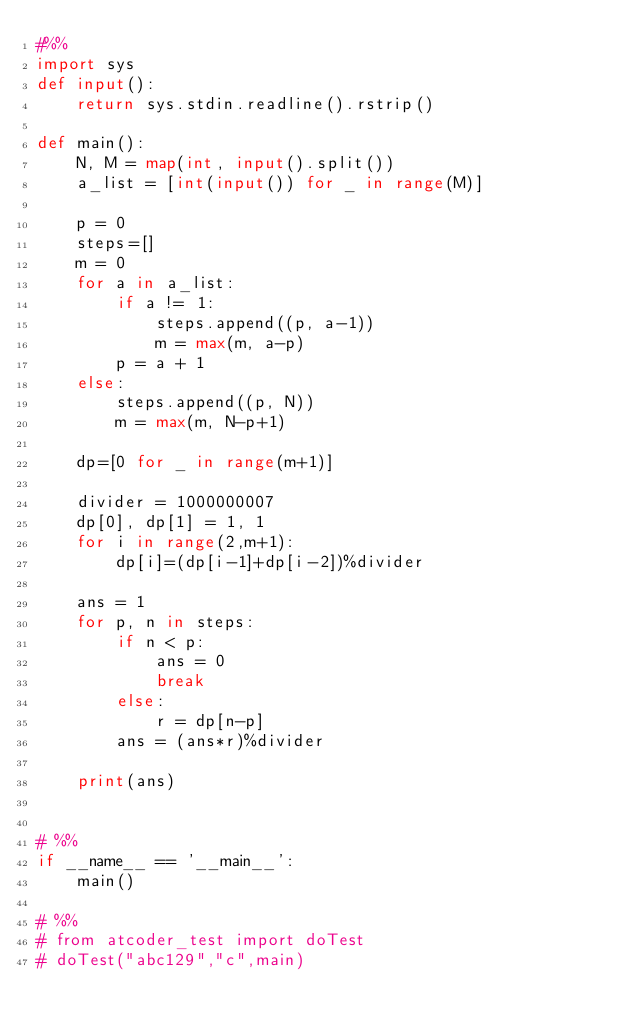Convert code to text. <code><loc_0><loc_0><loc_500><loc_500><_Python_>#%%
import sys
def input():
    return sys.stdin.readline().rstrip()

def main():
    N, M = map(int, input().split())
    a_list = [int(input()) for _ in range(M)]

    p = 0
    steps=[]
    m = 0
    for a in a_list:
        if a != 1:
            steps.append((p, a-1))
            m = max(m, a-p)
        p = a + 1
    else:
        steps.append((p, N))
        m = max(m, N-p+1)

    dp=[0 for _ in range(m+1)]

    divider = 1000000007
    dp[0], dp[1] = 1, 1
    for i in range(2,m+1):
        dp[i]=(dp[i-1]+dp[i-2])%divider

    ans = 1
    for p, n in steps:
        if n < p:
            ans = 0
            break
        else:
            r = dp[n-p]
        ans = (ans*r)%divider 

    print(ans)
        

# %%
if __name__ == '__main__':
    main()

# %%
# from atcoder_test import doTest
# doTest("abc129","c",main)</code> 